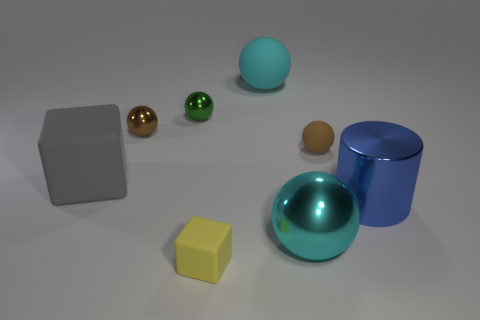There is a matte thing that is behind the small brown object that is on the right side of the large cyan metallic ball; how big is it?
Your answer should be compact. Large. What size is the matte cube that is behind the large object on the right side of the small rubber object right of the small yellow matte block?
Provide a short and direct response. Large. There is a small matte object that is behind the big metallic sphere; is its shape the same as the rubber thing behind the green sphere?
Your response must be concise. Yes. How many other objects are there of the same color as the big block?
Offer a terse response. 0. Do the matte thing that is in front of the blue metallic cylinder and the small brown rubber thing have the same size?
Offer a very short reply. Yes. Do the tiny thing in front of the gray block and the brown thing to the left of the tiny cube have the same material?
Your response must be concise. No. Are there any cubes that have the same size as the brown metal thing?
Provide a short and direct response. Yes. There is a cyan object behind the gray matte object that is behind the ball that is in front of the big gray matte thing; what shape is it?
Your response must be concise. Sphere. Are there more brown rubber things in front of the cyan matte ball than yellow balls?
Your response must be concise. Yes. Is there a gray rubber thing that has the same shape as the green metal thing?
Your answer should be very brief. No. 